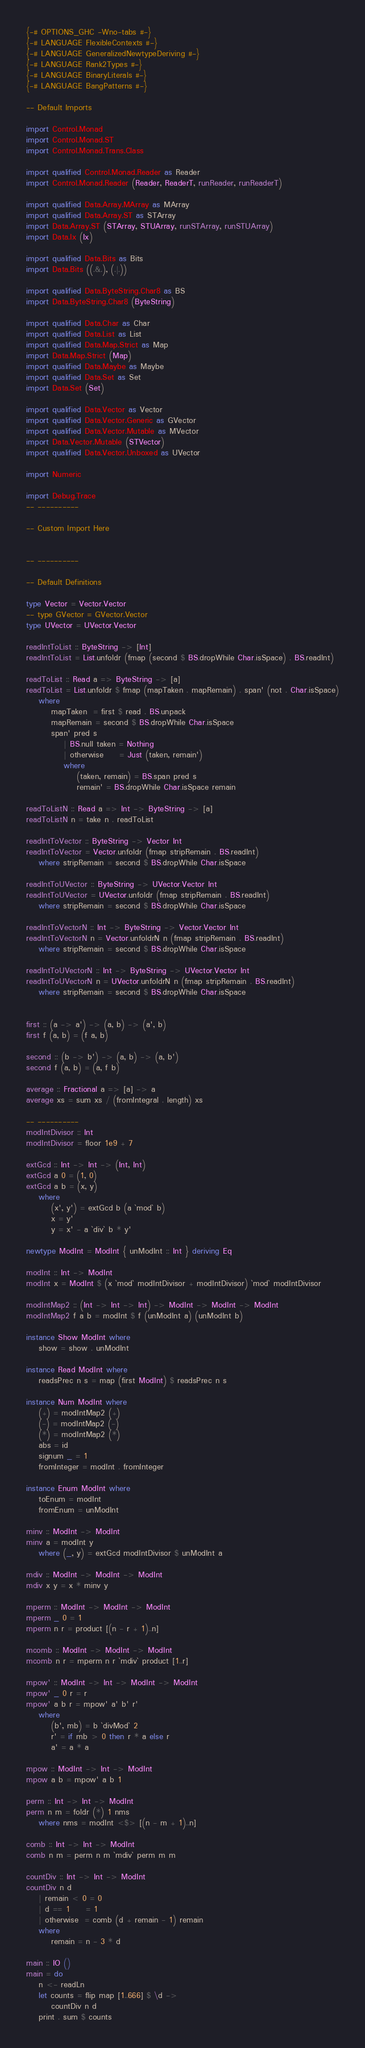Convert code to text. <code><loc_0><loc_0><loc_500><loc_500><_Haskell_>{-# OPTIONS_GHC -Wno-tabs #-}
{-# LANGUAGE FlexibleContexts #-}
{-# LANGUAGE GeneralizedNewtypeDeriving #-}
{-# LANGUAGE Rank2Types #-}
{-# LANGUAGE BinaryLiterals #-}
{-# LANGUAGE BangPatterns #-}

-- Default Imports

import Control.Monad
import Control.Monad.ST
import Control.Monad.Trans.Class

import qualified Control.Monad.Reader as Reader
import Control.Monad.Reader (Reader, ReaderT, runReader, runReaderT)

import qualified Data.Array.MArray as MArray
import qualified Data.Array.ST as STArray
import Data.Array.ST (STArray, STUArray, runSTArray, runSTUArray)
import Data.Ix (Ix)

import qualified Data.Bits as Bits
import Data.Bits ((.&.), (.|.))

import qualified Data.ByteString.Char8 as BS
import Data.ByteString.Char8 (ByteString)

import qualified Data.Char as Char
import qualified Data.List as List
import qualified Data.Map.Strict as Map
import Data.Map.Strict (Map)
import qualified Data.Maybe as Maybe
import qualified Data.Set as Set
import Data.Set (Set)

import qualified Data.Vector as Vector
import qualified Data.Vector.Generic as GVector
import qualified Data.Vector.Mutable as MVector
import Data.Vector.Mutable (STVector)
import qualified Data.Vector.Unboxed as UVector

import Numeric

import Debug.Trace
-- ----------

-- Custom Import Here


-- ----------

-- Default Definitions

type Vector = Vector.Vector
-- type GVector = GVector.Vector
type UVector = UVector.Vector

readIntToList :: ByteString -> [Int]
readIntToList = List.unfoldr (fmap (second $ BS.dropWhile Char.isSpace) . BS.readInt)

readToList :: Read a => ByteString -> [a]
readToList = List.unfoldr $ fmap (mapTaken . mapRemain) . span' (not . Char.isSpace)
	where
		mapTaken  = first $ read . BS.unpack
		mapRemain = second $ BS.dropWhile Char.isSpace
		span' pred s
			| BS.null taken = Nothing
			| otherwise     = Just (taken, remain')
			where
				(taken, remain) = BS.span pred s
				remain' = BS.dropWhile Char.isSpace remain

readToListN :: Read a => Int -> ByteString -> [a]
readToListN n = take n . readToList

readIntToVector :: ByteString -> Vector Int
readIntToVector = Vector.unfoldr (fmap stripRemain . BS.readInt)
	where stripRemain = second $ BS.dropWhile Char.isSpace

readIntToUVector :: ByteString -> UVector.Vector Int
readIntToUVector = UVector.unfoldr (fmap stripRemain . BS.readInt)
	where stripRemain = second $ BS.dropWhile Char.isSpace

readIntToVectorN :: Int -> ByteString -> Vector.Vector Int
readIntToVectorN n = Vector.unfoldrN n (fmap stripRemain . BS.readInt)
	where stripRemain = second $ BS.dropWhile Char.isSpace

readIntToUVectorN :: Int -> ByteString -> UVector.Vector Int
readIntToUVectorN n = UVector.unfoldrN n (fmap stripRemain . BS.readInt)
	where stripRemain = second $ BS.dropWhile Char.isSpace


first :: (a -> a') -> (a, b) -> (a', b)
first f (a, b) = (f a, b)

second :: (b -> b') -> (a, b) -> (a, b')
second f (a, b) = (a, f b)

average :: Fractional a => [a] -> a
average xs = sum xs / (fromIntegral . length) xs

-- ----------
modIntDivisor :: Int
modIntDivisor = floor 1e9 + 7

extGcd :: Int -> Int -> (Int, Int)
extGcd a 0 = (1, 0)
extGcd a b = (x, y)
	where
		(x', y') = extGcd b (a `mod` b)
		x = y'
		y = x' - a `div` b * y'

newtype ModInt = ModInt { unModInt :: Int } deriving Eq

modInt :: Int -> ModInt
modInt x = ModInt $ (x `mod` modIntDivisor + modIntDivisor) `mod` modIntDivisor

modIntMap2 :: (Int -> Int -> Int) -> ModInt -> ModInt -> ModInt
modIntMap2 f a b = modInt $ f (unModInt a) (unModInt b)

instance Show ModInt where
	show = show . unModInt

instance Read ModInt where
	readsPrec n s = map (first ModInt) $ readsPrec n s

instance Num ModInt where
	(+) = modIntMap2 (+)
	(-) = modIntMap2 (-)
	(*) = modIntMap2 (*)
	abs = id
	signum _ = 1
	fromInteger = modInt . fromInteger

instance Enum ModInt where
	toEnum = modInt
	fromEnum = unModInt

minv :: ModInt -> ModInt
minv a = modInt y
	where (_, y) = extGcd modIntDivisor $ unModInt a

mdiv :: ModInt -> ModInt -> ModInt
mdiv x y = x * minv y

mperm :: ModInt -> ModInt -> ModInt
mperm _ 0 = 1
mperm n r = product [(n - r + 1)..n]

mcomb :: ModInt -> ModInt -> ModInt
mcomb n r = mperm n r `mdiv` product [1..r]

mpow' :: ModInt -> Int -> ModInt -> ModInt
mpow' _ 0 r = r
mpow' a b r = mpow' a' b' r'
	where
		(b', mb) = b `divMod` 2
		r' = if mb > 0 then r * a else r
		a' = a * a

mpow :: ModInt -> Int -> ModInt
mpow a b = mpow' a b 1

perm :: Int -> Int -> ModInt
perm n m = foldr (*) 1 nms
	where nms = modInt <$> [(n - m + 1)..n]

comb :: Int -> Int -> ModInt
comb n m = perm n m `mdiv` perm m m

countDiv :: Int -> Int -> ModInt
countDiv n d
	| remain < 0 = 0
	| d == 1     = 1
	| otherwise  = comb (d + remain - 1) remain
	where
		remain = n - 3 * d

main :: IO ()
main = do
	n <- readLn
	let counts = flip map [1..666] $ \d ->
		countDiv n d
	print . sum $ counts
</code> 